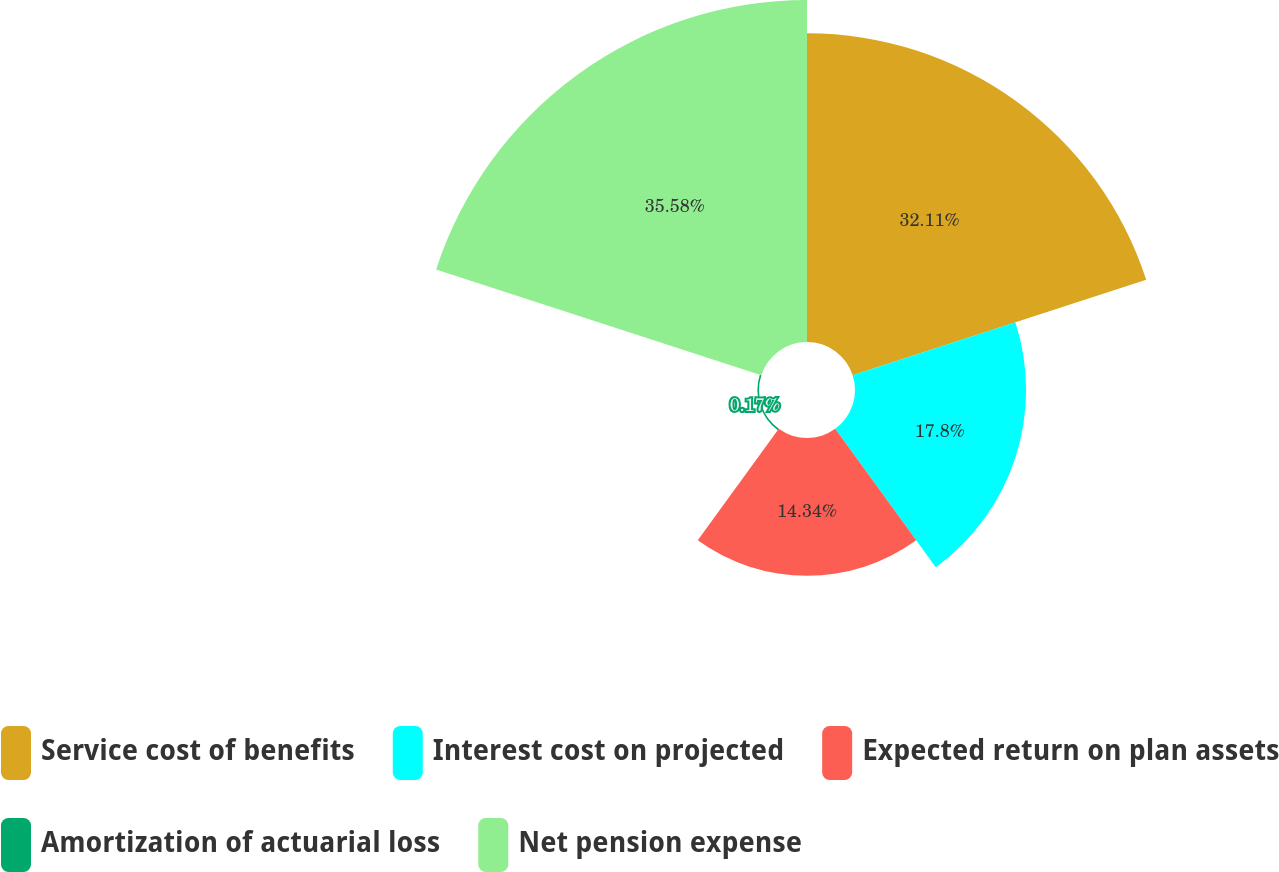<chart> <loc_0><loc_0><loc_500><loc_500><pie_chart><fcel>Service cost of benefits<fcel>Interest cost on projected<fcel>Expected return on plan assets<fcel>Amortization of actuarial loss<fcel>Net pension expense<nl><fcel>32.11%<fcel>17.8%<fcel>14.34%<fcel>0.17%<fcel>35.58%<nl></chart> 